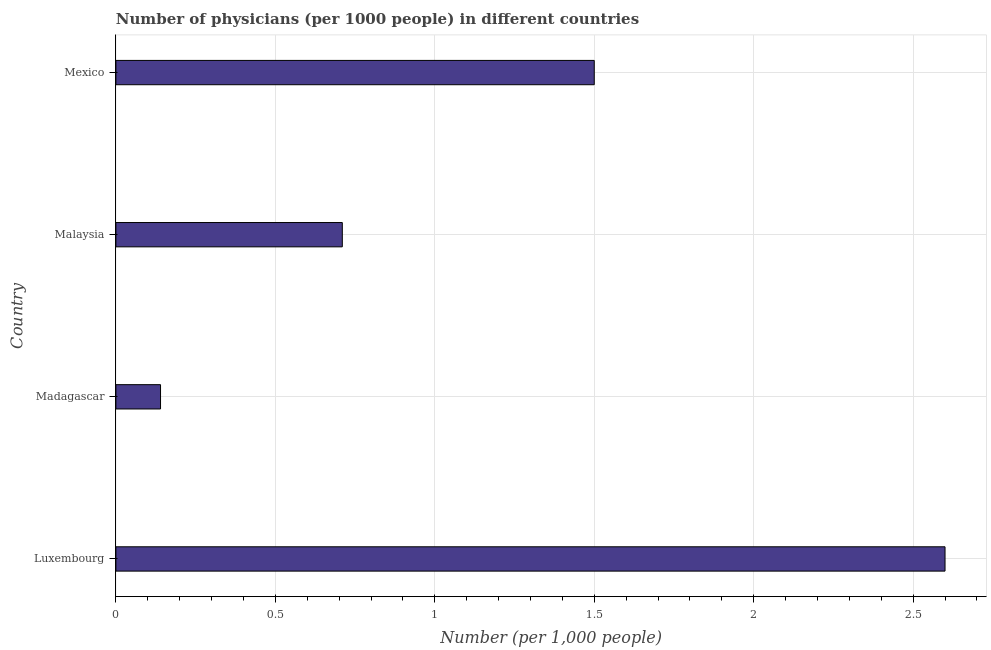Does the graph contain grids?
Provide a succinct answer. Yes. What is the title of the graph?
Provide a short and direct response. Number of physicians (per 1000 people) in different countries. What is the label or title of the X-axis?
Your answer should be very brief. Number (per 1,0 people). What is the number of physicians in Malaysia?
Ensure brevity in your answer.  0.71. Across all countries, what is the minimum number of physicians?
Make the answer very short. 0.14. In which country was the number of physicians maximum?
Offer a very short reply. Luxembourg. In which country was the number of physicians minimum?
Make the answer very short. Madagascar. What is the sum of the number of physicians?
Provide a short and direct response. 4.95. What is the average number of physicians per country?
Your answer should be very brief. 1.24. What is the median number of physicians?
Your answer should be compact. 1.1. What is the ratio of the number of physicians in Luxembourg to that in Mexico?
Provide a short and direct response. 1.73. Is the difference between the number of physicians in Luxembourg and Mexico greater than the difference between any two countries?
Make the answer very short. No. What is the difference between the highest and the second highest number of physicians?
Make the answer very short. 1.1. What is the difference between the highest and the lowest number of physicians?
Make the answer very short. 2.46. How many bars are there?
Offer a terse response. 4. Are all the bars in the graph horizontal?
Provide a succinct answer. Yes. How many countries are there in the graph?
Your response must be concise. 4. What is the difference between two consecutive major ticks on the X-axis?
Your response must be concise. 0.5. Are the values on the major ticks of X-axis written in scientific E-notation?
Give a very brief answer. No. What is the Number (per 1,000 people) in Luxembourg?
Your answer should be compact. 2.6. What is the Number (per 1,000 people) in Madagascar?
Your answer should be compact. 0.14. What is the Number (per 1,000 people) of Malaysia?
Provide a succinct answer. 0.71. What is the Number (per 1,000 people) of Mexico?
Keep it short and to the point. 1.5. What is the difference between the Number (per 1,000 people) in Luxembourg and Madagascar?
Your answer should be very brief. 2.46. What is the difference between the Number (per 1,000 people) in Luxembourg and Malaysia?
Offer a terse response. 1.89. What is the difference between the Number (per 1,000 people) in Madagascar and Malaysia?
Ensure brevity in your answer.  -0.57. What is the difference between the Number (per 1,000 people) in Madagascar and Mexico?
Keep it short and to the point. -1.36. What is the difference between the Number (per 1,000 people) in Malaysia and Mexico?
Your answer should be very brief. -0.79. What is the ratio of the Number (per 1,000 people) in Luxembourg to that in Madagascar?
Ensure brevity in your answer.  18.57. What is the ratio of the Number (per 1,000 people) in Luxembourg to that in Malaysia?
Your answer should be very brief. 3.66. What is the ratio of the Number (per 1,000 people) in Luxembourg to that in Mexico?
Ensure brevity in your answer.  1.73. What is the ratio of the Number (per 1,000 people) in Madagascar to that in Malaysia?
Your response must be concise. 0.2. What is the ratio of the Number (per 1,000 people) in Madagascar to that in Mexico?
Provide a succinct answer. 0.09. What is the ratio of the Number (per 1,000 people) in Malaysia to that in Mexico?
Offer a very short reply. 0.47. 